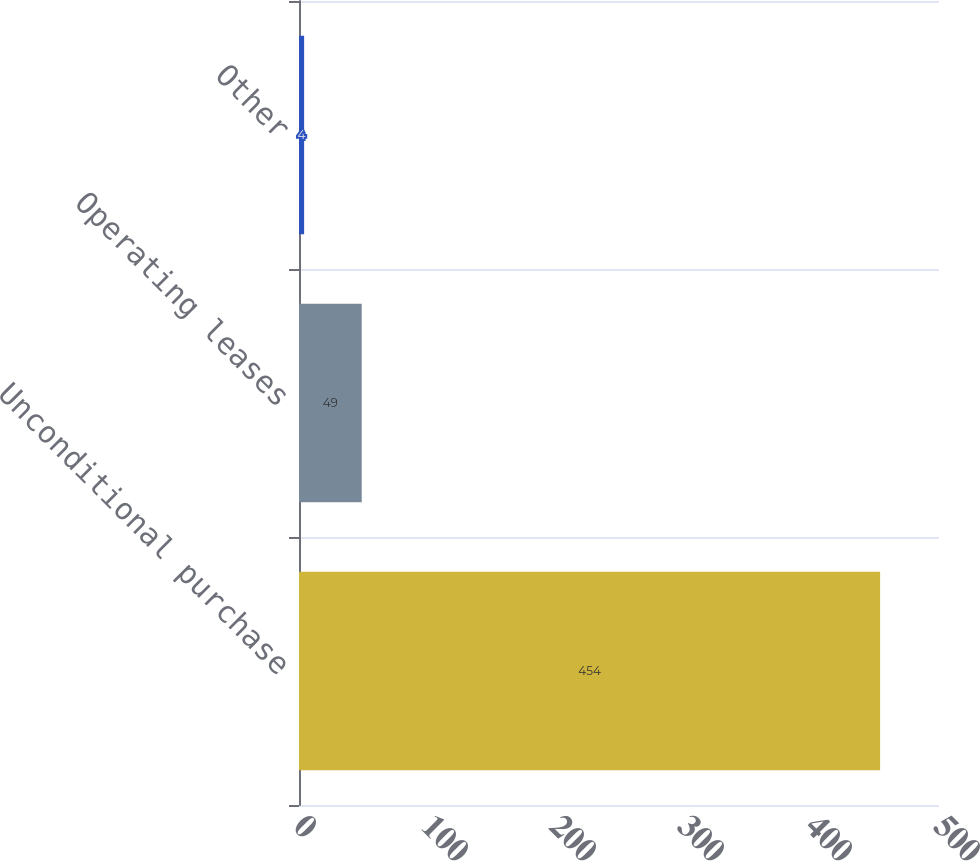<chart> <loc_0><loc_0><loc_500><loc_500><bar_chart><fcel>Unconditional purchase<fcel>Operating leases<fcel>Other<nl><fcel>454<fcel>49<fcel>4<nl></chart> 